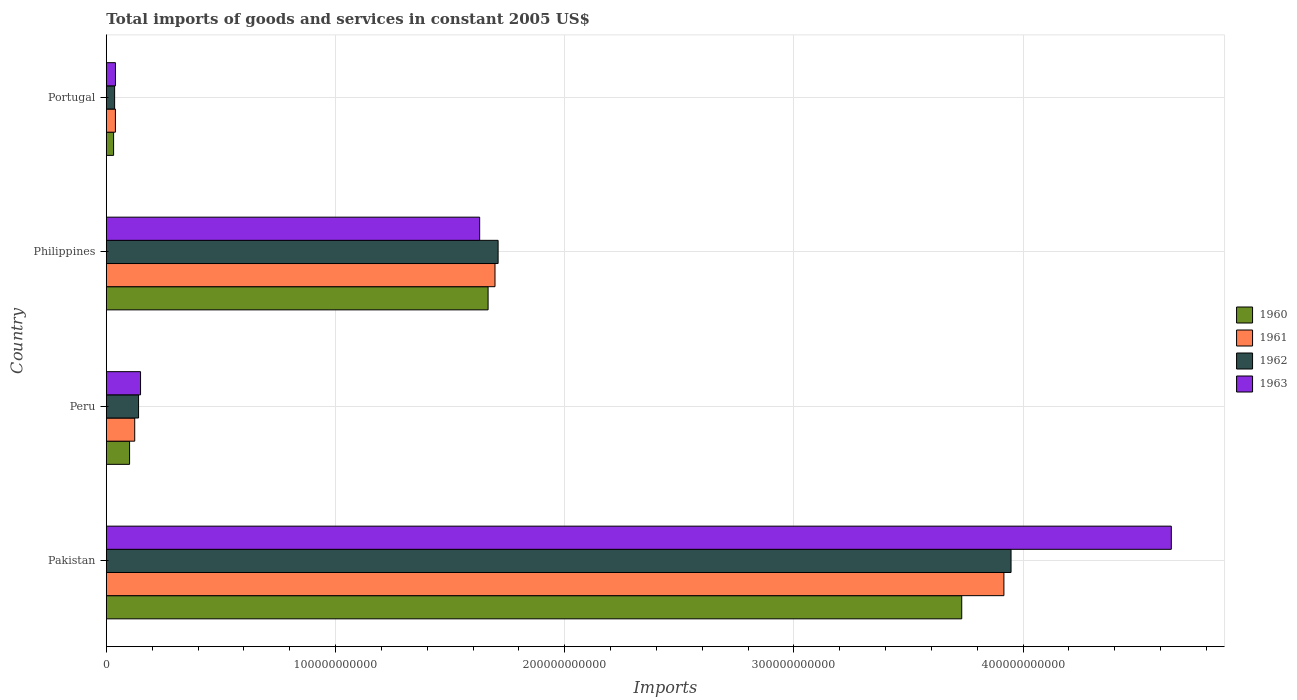Are the number of bars per tick equal to the number of legend labels?
Provide a short and direct response. Yes. How many bars are there on the 3rd tick from the top?
Your answer should be compact. 4. In how many cases, is the number of bars for a given country not equal to the number of legend labels?
Your response must be concise. 0. What is the total imports of goods and services in 1962 in Peru?
Provide a short and direct response. 1.41e+1. Across all countries, what is the maximum total imports of goods and services in 1961?
Offer a terse response. 3.92e+11. Across all countries, what is the minimum total imports of goods and services in 1960?
Provide a short and direct response. 3.17e+09. In which country was the total imports of goods and services in 1960 maximum?
Offer a very short reply. Pakistan. In which country was the total imports of goods and services in 1962 minimum?
Your answer should be compact. Portugal. What is the total total imports of goods and services in 1960 in the graph?
Your answer should be compact. 5.53e+11. What is the difference between the total imports of goods and services in 1961 in Pakistan and that in Philippines?
Your answer should be very brief. 2.22e+11. What is the difference between the total imports of goods and services in 1963 in Portugal and the total imports of goods and services in 1962 in Peru?
Provide a succinct answer. -1.01e+1. What is the average total imports of goods and services in 1963 per country?
Offer a very short reply. 1.62e+11. What is the difference between the total imports of goods and services in 1962 and total imports of goods and services in 1961 in Pakistan?
Ensure brevity in your answer.  3.12e+09. What is the ratio of the total imports of goods and services in 1962 in Pakistan to that in Portugal?
Your response must be concise. 109.08. What is the difference between the highest and the second highest total imports of goods and services in 1963?
Your response must be concise. 3.02e+11. What is the difference between the highest and the lowest total imports of goods and services in 1961?
Make the answer very short. 3.88e+11. What does the 1st bar from the top in Philippines represents?
Ensure brevity in your answer.  1963. How many countries are there in the graph?
Keep it short and to the point. 4. What is the difference between two consecutive major ticks on the X-axis?
Keep it short and to the point. 1.00e+11. Does the graph contain any zero values?
Your answer should be very brief. No. Does the graph contain grids?
Your answer should be compact. Yes. How many legend labels are there?
Provide a succinct answer. 4. What is the title of the graph?
Offer a terse response. Total imports of goods and services in constant 2005 US$. Does "1978" appear as one of the legend labels in the graph?
Provide a succinct answer. No. What is the label or title of the X-axis?
Offer a terse response. Imports. What is the label or title of the Y-axis?
Keep it short and to the point. Country. What is the Imports of 1960 in Pakistan?
Your response must be concise. 3.73e+11. What is the Imports of 1961 in Pakistan?
Ensure brevity in your answer.  3.92e+11. What is the Imports in 1962 in Pakistan?
Give a very brief answer. 3.95e+11. What is the Imports in 1963 in Pakistan?
Ensure brevity in your answer.  4.65e+11. What is the Imports of 1960 in Peru?
Offer a terse response. 1.01e+1. What is the Imports of 1961 in Peru?
Give a very brief answer. 1.24e+1. What is the Imports of 1962 in Peru?
Ensure brevity in your answer.  1.41e+1. What is the Imports of 1963 in Peru?
Your response must be concise. 1.49e+1. What is the Imports of 1960 in Philippines?
Offer a terse response. 1.67e+11. What is the Imports of 1961 in Philippines?
Make the answer very short. 1.70e+11. What is the Imports in 1962 in Philippines?
Make the answer very short. 1.71e+11. What is the Imports of 1963 in Philippines?
Offer a terse response. 1.63e+11. What is the Imports in 1960 in Portugal?
Provide a short and direct response. 3.17e+09. What is the Imports in 1961 in Portugal?
Provide a succinct answer. 3.96e+09. What is the Imports in 1962 in Portugal?
Ensure brevity in your answer.  3.62e+09. What is the Imports in 1963 in Portugal?
Your response must be concise. 3.98e+09. Across all countries, what is the maximum Imports of 1960?
Your response must be concise. 3.73e+11. Across all countries, what is the maximum Imports in 1961?
Your answer should be very brief. 3.92e+11. Across all countries, what is the maximum Imports in 1962?
Provide a succinct answer. 3.95e+11. Across all countries, what is the maximum Imports of 1963?
Make the answer very short. 4.65e+11. Across all countries, what is the minimum Imports in 1960?
Give a very brief answer. 3.17e+09. Across all countries, what is the minimum Imports in 1961?
Your answer should be compact. 3.96e+09. Across all countries, what is the minimum Imports of 1962?
Provide a short and direct response. 3.62e+09. Across all countries, what is the minimum Imports in 1963?
Give a very brief answer. 3.98e+09. What is the total Imports of 1960 in the graph?
Your answer should be very brief. 5.53e+11. What is the total Imports in 1961 in the graph?
Offer a terse response. 5.78e+11. What is the total Imports in 1962 in the graph?
Offer a very short reply. 5.83e+11. What is the total Imports of 1963 in the graph?
Your answer should be compact. 6.47e+11. What is the difference between the Imports of 1960 in Pakistan and that in Peru?
Your response must be concise. 3.63e+11. What is the difference between the Imports in 1961 in Pakistan and that in Peru?
Offer a terse response. 3.79e+11. What is the difference between the Imports of 1962 in Pakistan and that in Peru?
Make the answer very short. 3.81e+11. What is the difference between the Imports of 1963 in Pakistan and that in Peru?
Your answer should be compact. 4.50e+11. What is the difference between the Imports in 1960 in Pakistan and that in Philippines?
Offer a very short reply. 2.07e+11. What is the difference between the Imports of 1961 in Pakistan and that in Philippines?
Offer a terse response. 2.22e+11. What is the difference between the Imports in 1962 in Pakistan and that in Philippines?
Provide a short and direct response. 2.24e+11. What is the difference between the Imports of 1963 in Pakistan and that in Philippines?
Offer a terse response. 3.02e+11. What is the difference between the Imports in 1960 in Pakistan and that in Portugal?
Your answer should be compact. 3.70e+11. What is the difference between the Imports of 1961 in Pakistan and that in Portugal?
Your answer should be compact. 3.88e+11. What is the difference between the Imports of 1962 in Pakistan and that in Portugal?
Make the answer very short. 3.91e+11. What is the difference between the Imports in 1963 in Pakistan and that in Portugal?
Offer a very short reply. 4.61e+11. What is the difference between the Imports of 1960 in Peru and that in Philippines?
Offer a terse response. -1.56e+11. What is the difference between the Imports in 1961 in Peru and that in Philippines?
Provide a short and direct response. -1.57e+11. What is the difference between the Imports of 1962 in Peru and that in Philippines?
Offer a terse response. -1.57e+11. What is the difference between the Imports in 1963 in Peru and that in Philippines?
Make the answer very short. -1.48e+11. What is the difference between the Imports in 1960 in Peru and that in Portugal?
Provide a succinct answer. 6.98e+09. What is the difference between the Imports in 1961 in Peru and that in Portugal?
Offer a very short reply. 8.43e+09. What is the difference between the Imports in 1962 in Peru and that in Portugal?
Make the answer very short. 1.04e+1. What is the difference between the Imports of 1963 in Peru and that in Portugal?
Offer a very short reply. 1.10e+1. What is the difference between the Imports of 1960 in Philippines and that in Portugal?
Offer a very short reply. 1.63e+11. What is the difference between the Imports of 1961 in Philippines and that in Portugal?
Offer a terse response. 1.66e+11. What is the difference between the Imports of 1962 in Philippines and that in Portugal?
Your answer should be compact. 1.67e+11. What is the difference between the Imports of 1963 in Philippines and that in Portugal?
Make the answer very short. 1.59e+11. What is the difference between the Imports in 1960 in Pakistan and the Imports in 1961 in Peru?
Ensure brevity in your answer.  3.61e+11. What is the difference between the Imports of 1960 in Pakistan and the Imports of 1962 in Peru?
Make the answer very short. 3.59e+11. What is the difference between the Imports of 1960 in Pakistan and the Imports of 1963 in Peru?
Provide a succinct answer. 3.58e+11. What is the difference between the Imports in 1961 in Pakistan and the Imports in 1962 in Peru?
Your answer should be compact. 3.78e+11. What is the difference between the Imports of 1961 in Pakistan and the Imports of 1963 in Peru?
Your answer should be very brief. 3.77e+11. What is the difference between the Imports of 1962 in Pakistan and the Imports of 1963 in Peru?
Provide a succinct answer. 3.80e+11. What is the difference between the Imports of 1960 in Pakistan and the Imports of 1961 in Philippines?
Offer a very short reply. 2.04e+11. What is the difference between the Imports in 1960 in Pakistan and the Imports in 1962 in Philippines?
Offer a very short reply. 2.02e+11. What is the difference between the Imports of 1960 in Pakistan and the Imports of 1963 in Philippines?
Provide a short and direct response. 2.10e+11. What is the difference between the Imports in 1961 in Pakistan and the Imports in 1962 in Philippines?
Provide a succinct answer. 2.21e+11. What is the difference between the Imports of 1961 in Pakistan and the Imports of 1963 in Philippines?
Make the answer very short. 2.29e+11. What is the difference between the Imports in 1962 in Pakistan and the Imports in 1963 in Philippines?
Your response must be concise. 2.32e+11. What is the difference between the Imports in 1960 in Pakistan and the Imports in 1961 in Portugal?
Make the answer very short. 3.69e+11. What is the difference between the Imports in 1960 in Pakistan and the Imports in 1962 in Portugal?
Your answer should be very brief. 3.70e+11. What is the difference between the Imports of 1960 in Pakistan and the Imports of 1963 in Portugal?
Provide a succinct answer. 3.69e+11. What is the difference between the Imports in 1961 in Pakistan and the Imports in 1962 in Portugal?
Your answer should be very brief. 3.88e+11. What is the difference between the Imports of 1961 in Pakistan and the Imports of 1963 in Portugal?
Offer a terse response. 3.88e+11. What is the difference between the Imports of 1962 in Pakistan and the Imports of 1963 in Portugal?
Your answer should be very brief. 3.91e+11. What is the difference between the Imports of 1960 in Peru and the Imports of 1961 in Philippines?
Ensure brevity in your answer.  -1.59e+11. What is the difference between the Imports of 1960 in Peru and the Imports of 1962 in Philippines?
Ensure brevity in your answer.  -1.61e+11. What is the difference between the Imports of 1960 in Peru and the Imports of 1963 in Philippines?
Offer a terse response. -1.53e+11. What is the difference between the Imports of 1961 in Peru and the Imports of 1962 in Philippines?
Ensure brevity in your answer.  -1.59e+11. What is the difference between the Imports in 1961 in Peru and the Imports in 1963 in Philippines?
Keep it short and to the point. -1.51e+11. What is the difference between the Imports of 1962 in Peru and the Imports of 1963 in Philippines?
Ensure brevity in your answer.  -1.49e+11. What is the difference between the Imports of 1960 in Peru and the Imports of 1961 in Portugal?
Give a very brief answer. 6.19e+09. What is the difference between the Imports in 1960 in Peru and the Imports in 1962 in Portugal?
Make the answer very short. 6.53e+09. What is the difference between the Imports in 1960 in Peru and the Imports in 1963 in Portugal?
Give a very brief answer. 6.17e+09. What is the difference between the Imports of 1961 in Peru and the Imports of 1962 in Portugal?
Offer a terse response. 8.77e+09. What is the difference between the Imports of 1961 in Peru and the Imports of 1963 in Portugal?
Your answer should be very brief. 8.41e+09. What is the difference between the Imports in 1962 in Peru and the Imports in 1963 in Portugal?
Your answer should be compact. 1.01e+1. What is the difference between the Imports in 1960 in Philippines and the Imports in 1961 in Portugal?
Your response must be concise. 1.63e+11. What is the difference between the Imports in 1960 in Philippines and the Imports in 1962 in Portugal?
Offer a very short reply. 1.63e+11. What is the difference between the Imports of 1960 in Philippines and the Imports of 1963 in Portugal?
Offer a terse response. 1.63e+11. What is the difference between the Imports of 1961 in Philippines and the Imports of 1962 in Portugal?
Provide a succinct answer. 1.66e+11. What is the difference between the Imports of 1961 in Philippines and the Imports of 1963 in Portugal?
Keep it short and to the point. 1.66e+11. What is the difference between the Imports in 1962 in Philippines and the Imports in 1963 in Portugal?
Keep it short and to the point. 1.67e+11. What is the average Imports in 1960 per country?
Offer a very short reply. 1.38e+11. What is the average Imports in 1961 per country?
Keep it short and to the point. 1.44e+11. What is the average Imports of 1962 per country?
Give a very brief answer. 1.46e+11. What is the average Imports in 1963 per country?
Provide a succinct answer. 1.62e+11. What is the difference between the Imports of 1960 and Imports of 1961 in Pakistan?
Ensure brevity in your answer.  -1.84e+1. What is the difference between the Imports in 1960 and Imports in 1962 in Pakistan?
Your response must be concise. -2.15e+1. What is the difference between the Imports of 1960 and Imports of 1963 in Pakistan?
Your answer should be very brief. -9.14e+1. What is the difference between the Imports of 1961 and Imports of 1962 in Pakistan?
Your response must be concise. -3.12e+09. What is the difference between the Imports of 1961 and Imports of 1963 in Pakistan?
Ensure brevity in your answer.  -7.30e+1. What is the difference between the Imports of 1962 and Imports of 1963 in Pakistan?
Your response must be concise. -6.99e+1. What is the difference between the Imports in 1960 and Imports in 1961 in Peru?
Your answer should be compact. -2.24e+09. What is the difference between the Imports in 1960 and Imports in 1962 in Peru?
Your answer should be very brief. -3.92e+09. What is the difference between the Imports in 1960 and Imports in 1963 in Peru?
Your answer should be compact. -4.78e+09. What is the difference between the Imports of 1961 and Imports of 1962 in Peru?
Your answer should be compact. -1.68e+09. What is the difference between the Imports in 1961 and Imports in 1963 in Peru?
Keep it short and to the point. -2.54e+09. What is the difference between the Imports of 1962 and Imports of 1963 in Peru?
Offer a terse response. -8.62e+08. What is the difference between the Imports of 1960 and Imports of 1961 in Philippines?
Offer a terse response. -3.01e+09. What is the difference between the Imports of 1960 and Imports of 1962 in Philippines?
Your response must be concise. -4.37e+09. What is the difference between the Imports in 1960 and Imports in 1963 in Philippines?
Make the answer very short. 3.68e+09. What is the difference between the Imports in 1961 and Imports in 1962 in Philippines?
Provide a short and direct response. -1.36e+09. What is the difference between the Imports in 1961 and Imports in 1963 in Philippines?
Offer a terse response. 6.69e+09. What is the difference between the Imports in 1962 and Imports in 1963 in Philippines?
Provide a short and direct response. 8.04e+09. What is the difference between the Imports of 1960 and Imports of 1961 in Portugal?
Offer a terse response. -7.89e+08. What is the difference between the Imports of 1960 and Imports of 1962 in Portugal?
Offer a terse response. -4.52e+08. What is the difference between the Imports in 1960 and Imports in 1963 in Portugal?
Give a very brief answer. -8.09e+08. What is the difference between the Imports in 1961 and Imports in 1962 in Portugal?
Ensure brevity in your answer.  3.37e+08. What is the difference between the Imports of 1961 and Imports of 1963 in Portugal?
Your response must be concise. -2.01e+07. What is the difference between the Imports in 1962 and Imports in 1963 in Portugal?
Your answer should be very brief. -3.57e+08. What is the ratio of the Imports of 1960 in Pakistan to that in Peru?
Your answer should be compact. 36.79. What is the ratio of the Imports of 1961 in Pakistan to that in Peru?
Offer a terse response. 31.62. What is the ratio of the Imports of 1962 in Pakistan to that in Peru?
Ensure brevity in your answer.  28.07. What is the ratio of the Imports of 1963 in Pakistan to that in Peru?
Give a very brief answer. 31.13. What is the ratio of the Imports in 1960 in Pakistan to that in Philippines?
Provide a short and direct response. 2.24. What is the ratio of the Imports of 1961 in Pakistan to that in Philippines?
Your answer should be very brief. 2.31. What is the ratio of the Imports of 1962 in Pakistan to that in Philippines?
Keep it short and to the point. 2.31. What is the ratio of the Imports in 1963 in Pakistan to that in Philippines?
Offer a terse response. 2.85. What is the ratio of the Imports of 1960 in Pakistan to that in Portugal?
Your answer should be very brief. 117.86. What is the ratio of the Imports in 1961 in Pakistan to that in Portugal?
Your response must be concise. 99. What is the ratio of the Imports of 1962 in Pakistan to that in Portugal?
Offer a very short reply. 109.08. What is the ratio of the Imports in 1963 in Pakistan to that in Portugal?
Keep it short and to the point. 116.87. What is the ratio of the Imports in 1960 in Peru to that in Philippines?
Keep it short and to the point. 0.06. What is the ratio of the Imports in 1961 in Peru to that in Philippines?
Provide a succinct answer. 0.07. What is the ratio of the Imports of 1962 in Peru to that in Philippines?
Offer a terse response. 0.08. What is the ratio of the Imports of 1963 in Peru to that in Philippines?
Your answer should be very brief. 0.09. What is the ratio of the Imports of 1960 in Peru to that in Portugal?
Your answer should be compact. 3.2. What is the ratio of the Imports in 1961 in Peru to that in Portugal?
Give a very brief answer. 3.13. What is the ratio of the Imports of 1962 in Peru to that in Portugal?
Provide a short and direct response. 3.89. What is the ratio of the Imports of 1963 in Peru to that in Portugal?
Your answer should be compact. 3.75. What is the ratio of the Imports in 1960 in Philippines to that in Portugal?
Your answer should be compact. 52.6. What is the ratio of the Imports in 1961 in Philippines to that in Portugal?
Ensure brevity in your answer.  42.87. What is the ratio of the Imports in 1962 in Philippines to that in Portugal?
Your answer should be very brief. 47.23. What is the ratio of the Imports in 1963 in Philippines to that in Portugal?
Offer a very short reply. 40.97. What is the difference between the highest and the second highest Imports in 1960?
Provide a succinct answer. 2.07e+11. What is the difference between the highest and the second highest Imports in 1961?
Ensure brevity in your answer.  2.22e+11. What is the difference between the highest and the second highest Imports in 1962?
Keep it short and to the point. 2.24e+11. What is the difference between the highest and the second highest Imports of 1963?
Your answer should be very brief. 3.02e+11. What is the difference between the highest and the lowest Imports of 1960?
Give a very brief answer. 3.70e+11. What is the difference between the highest and the lowest Imports of 1961?
Your answer should be compact. 3.88e+11. What is the difference between the highest and the lowest Imports in 1962?
Your answer should be compact. 3.91e+11. What is the difference between the highest and the lowest Imports of 1963?
Provide a short and direct response. 4.61e+11. 